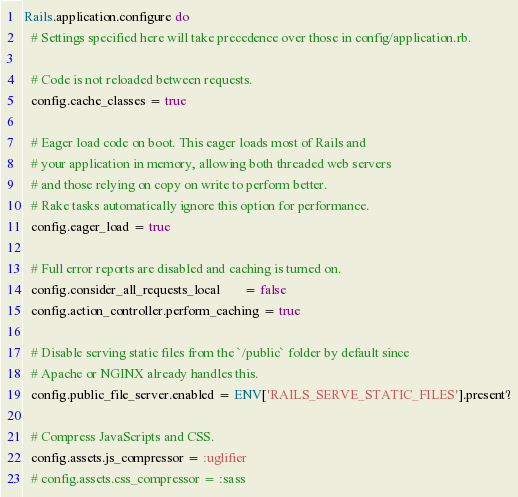<code> <loc_0><loc_0><loc_500><loc_500><_Ruby_>Rails.application.configure do
  # Settings specified here will take precedence over those in config/application.rb.

  # Code is not reloaded between requests.
  config.cache_classes = true

  # Eager load code on boot. This eager loads most of Rails and
  # your application in memory, allowing both threaded web servers
  # and those relying on copy on write to perform better.
  # Rake tasks automatically ignore this option for performance.
  config.eager_load = true

  # Full error reports are disabled and caching is turned on.
  config.consider_all_requests_local       = false
  config.action_controller.perform_caching = true

  # Disable serving static files from the `/public` folder by default since
  # Apache or NGINX already handles this.
  config.public_file_server.enabled = ENV['RAILS_SERVE_STATIC_FILES'].present?

  # Compress JavaScripts and CSS.
  config.assets.js_compressor = :uglifier
  # config.assets.css_compressor = :sass
</code> 